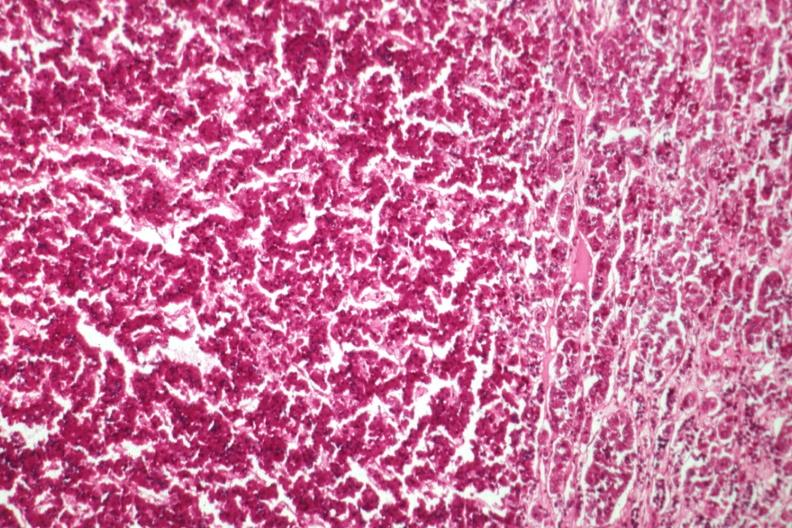s metastatic carcinoma prostate present?
Answer the question using a single word or phrase. No 